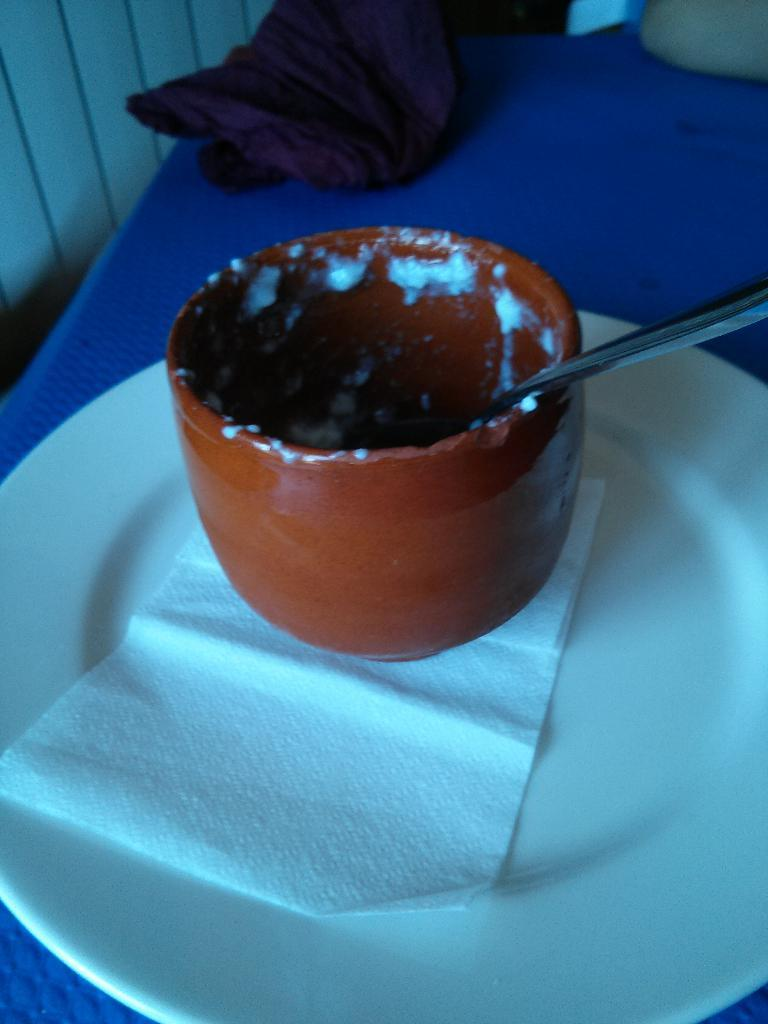What piece of furniture is present in the image? There is a table in the image. What is placed on the table? There is a cup, a spoon, and a plate with a tissue on it on the table. Are there any other objects on the table? Yes, there are other objects beside the plate on the table. What type of guide is present on the table in the image? There is no guide present on the table in the image. How many sticks are visible on the table in the image? There are no sticks visible on the table in the image. 